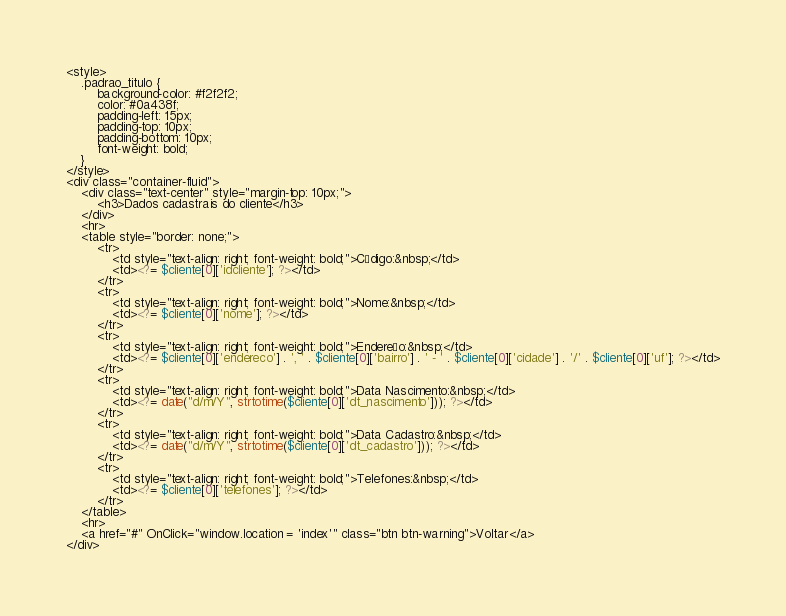<code> <loc_0><loc_0><loc_500><loc_500><_PHP_><style>
    .padrao_titulo {
        background-color: #f2f2f2;
        color: #0a438f;
        padding-left: 15px;
        padding-top: 10px;
        padding-bottom: 10px;
        font-weight: bold;
    }
</style>
<div class="container-fluid">
    <div class="text-center" style="margin-top: 10px;">
        <h3>Dados cadastrais do cliente</h3>
    </div>
    <hr>
    <table style="border: none;">
        <tr>
            <td style="text-align: right; font-weight: bold;">Código:&nbsp;</td>
            <td><?= $cliente[0]['idcliente']; ?></td>
        </tr>
        <tr>
            <td style="text-align: right; font-weight: bold;">Nome:&nbsp;</td>
            <td><?= $cliente[0]['nome']; ?></td>
        </tr>
        <tr>
            <td style="text-align: right; font-weight: bold;">Endereço:&nbsp;</td>
            <td><?= $cliente[0]['endereco'] . ', ' . $cliente[0]['bairro'] . ' - ' . $cliente[0]['cidade'] . '/' . $cliente[0]['uf']; ?></td>
        </tr>
        <tr>
            <td style="text-align: right; font-weight: bold;">Data Nascimento:&nbsp;</td>
            <td><?= date("d/m/Y", strtotime($cliente[0]['dt_nascimento'])); ?></td>
        </tr>
        <tr>
            <td style="text-align: right; font-weight: bold;">Data Cadastro:&nbsp;</td>
            <td><?= date("d/m/Y", strtotime($cliente[0]['dt_cadastro'])); ?></td>
        </tr>
        <tr>
            <td style="text-align: right; font-weight: bold;">Telefones:&nbsp;</td>
            <td><?= $cliente[0]['telefones']; ?></td>
        </tr>
    </table>
    <hr>
    <a href="#" OnClick="window.location = 'index'" class="btn btn-warning">Voltar</a>
</div></code> 